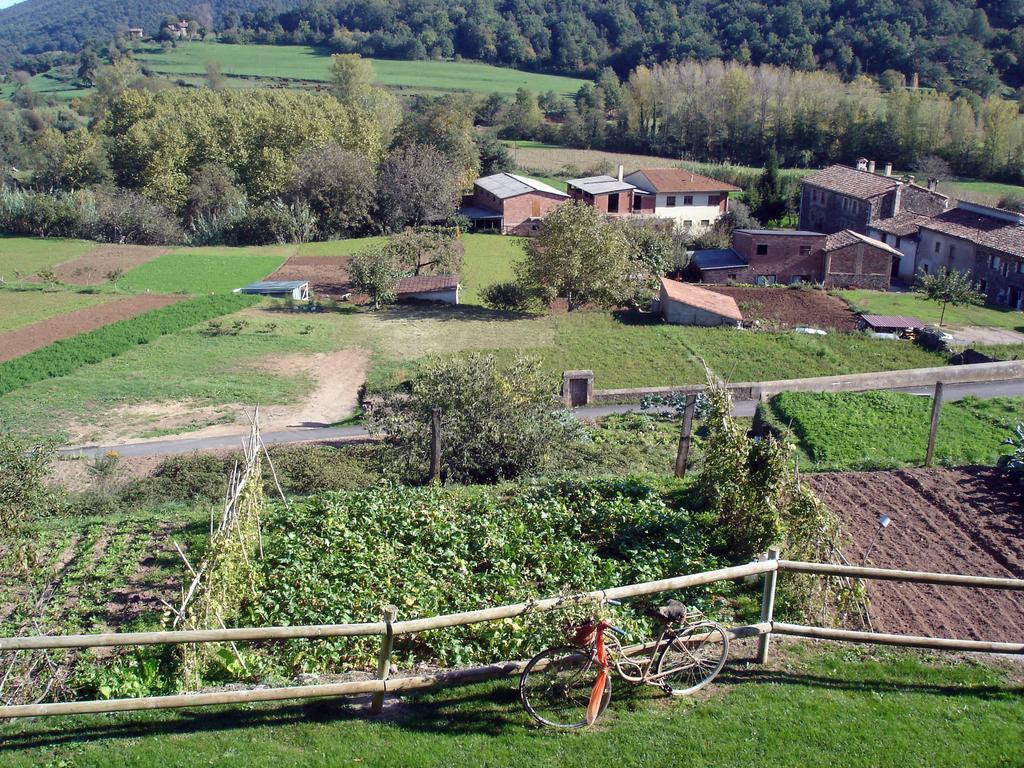Can you describe this image briefly? In this image there is a bicycle, wooden fencing and there are fields, houses and trees. 